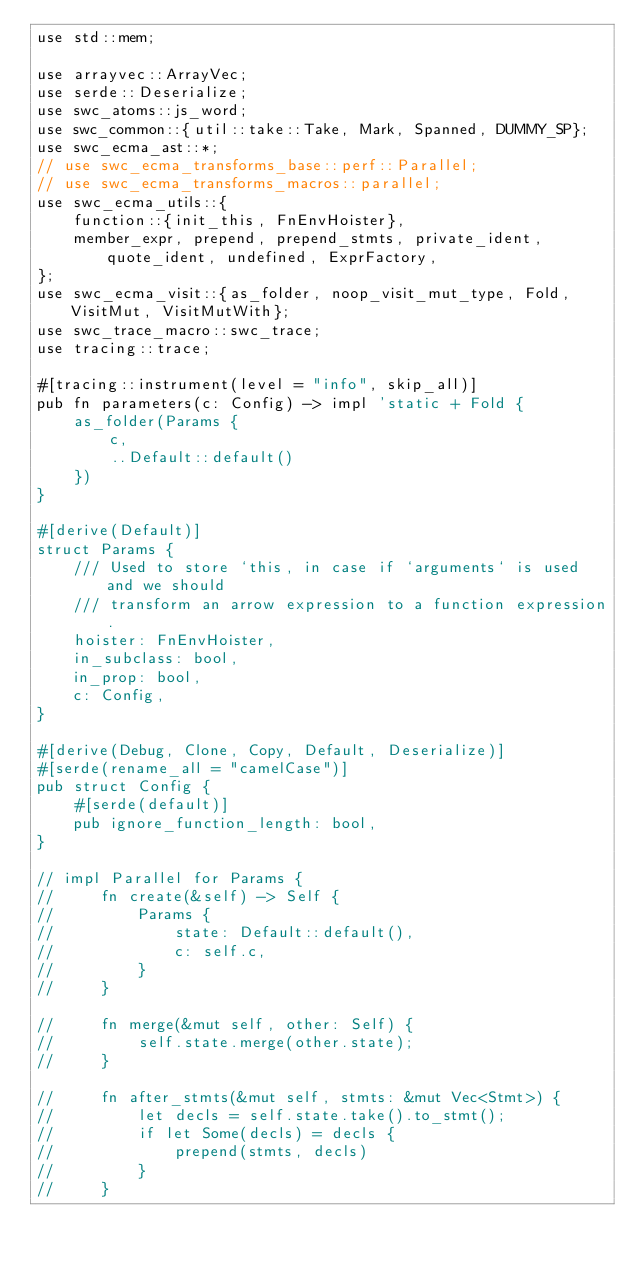<code> <loc_0><loc_0><loc_500><loc_500><_Rust_>use std::mem;

use arrayvec::ArrayVec;
use serde::Deserialize;
use swc_atoms::js_word;
use swc_common::{util::take::Take, Mark, Spanned, DUMMY_SP};
use swc_ecma_ast::*;
// use swc_ecma_transforms_base::perf::Parallel;
// use swc_ecma_transforms_macros::parallel;
use swc_ecma_utils::{
    function::{init_this, FnEnvHoister},
    member_expr, prepend, prepend_stmts, private_ident, quote_ident, undefined, ExprFactory,
};
use swc_ecma_visit::{as_folder, noop_visit_mut_type, Fold, VisitMut, VisitMutWith};
use swc_trace_macro::swc_trace;
use tracing::trace;

#[tracing::instrument(level = "info", skip_all)]
pub fn parameters(c: Config) -> impl 'static + Fold {
    as_folder(Params {
        c,
        ..Default::default()
    })
}

#[derive(Default)]
struct Params {
    /// Used to store `this, in case if `arguments` is used and we should
    /// transform an arrow expression to a function expression.
    hoister: FnEnvHoister,
    in_subclass: bool,
    in_prop: bool,
    c: Config,
}

#[derive(Debug, Clone, Copy, Default, Deserialize)]
#[serde(rename_all = "camelCase")]
pub struct Config {
    #[serde(default)]
    pub ignore_function_length: bool,
}

// impl Parallel for Params {
//     fn create(&self) -> Self {
//         Params {
//             state: Default::default(),
//             c: self.c,
//         }
//     }

//     fn merge(&mut self, other: Self) {
//         self.state.merge(other.state);
//     }

//     fn after_stmts(&mut self, stmts: &mut Vec<Stmt>) {
//         let decls = self.state.take().to_stmt();
//         if let Some(decls) = decls {
//             prepend(stmts, decls)
//         }
//     }
</code> 